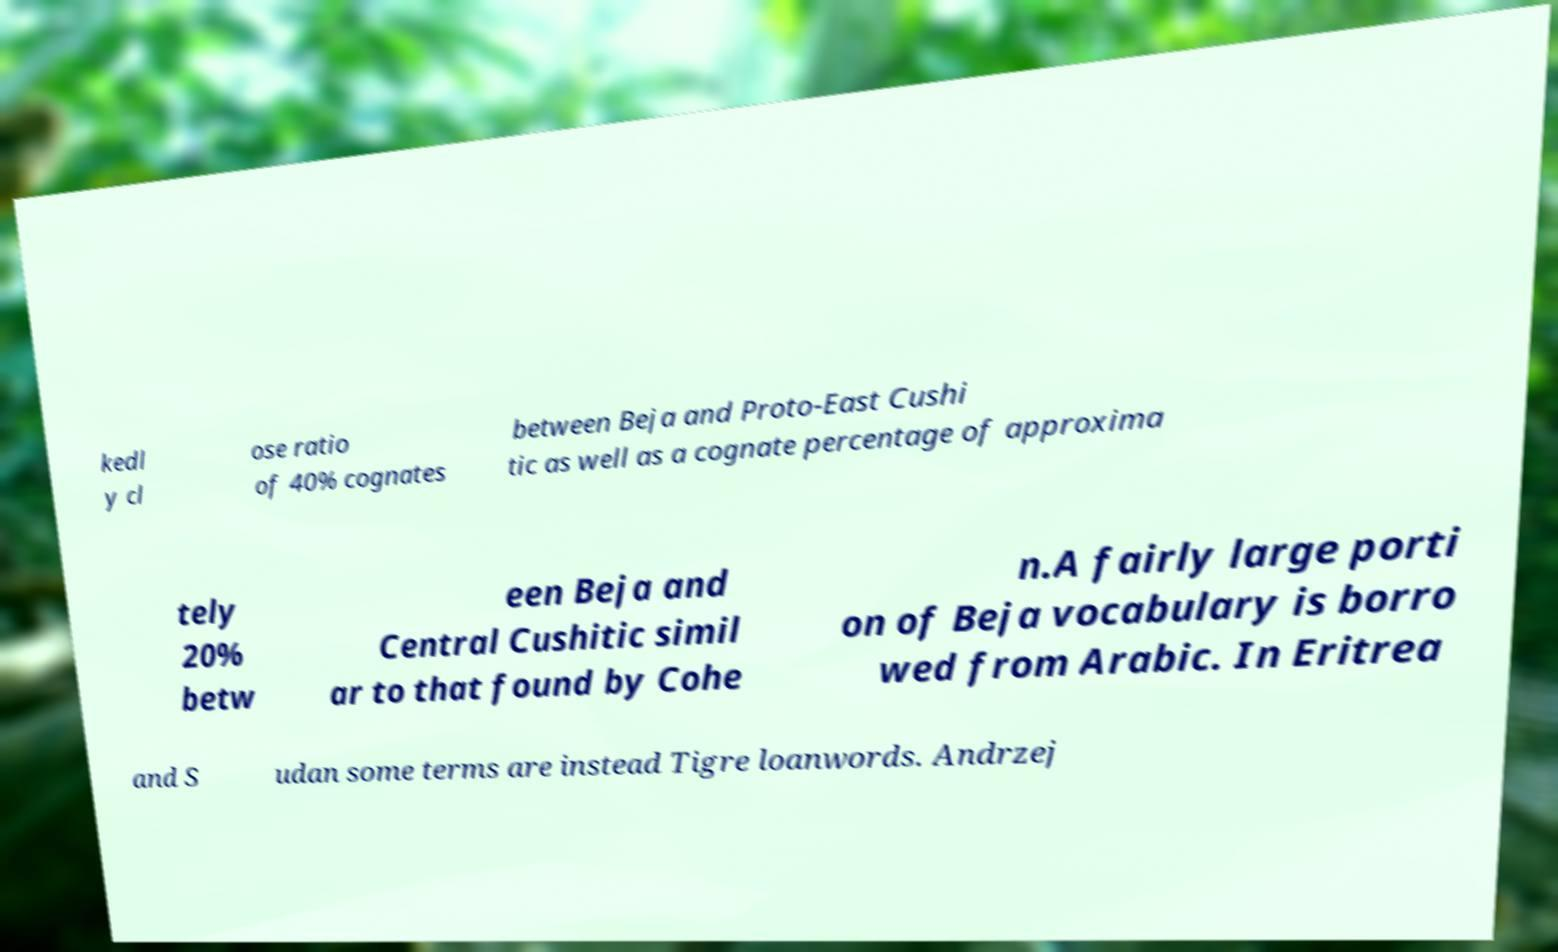For documentation purposes, I need the text within this image transcribed. Could you provide that? kedl y cl ose ratio of 40% cognates between Beja and Proto-East Cushi tic as well as a cognate percentage of approxima tely 20% betw een Beja and Central Cushitic simil ar to that found by Cohe n.A fairly large porti on of Beja vocabulary is borro wed from Arabic. In Eritrea and S udan some terms are instead Tigre loanwords. Andrzej 